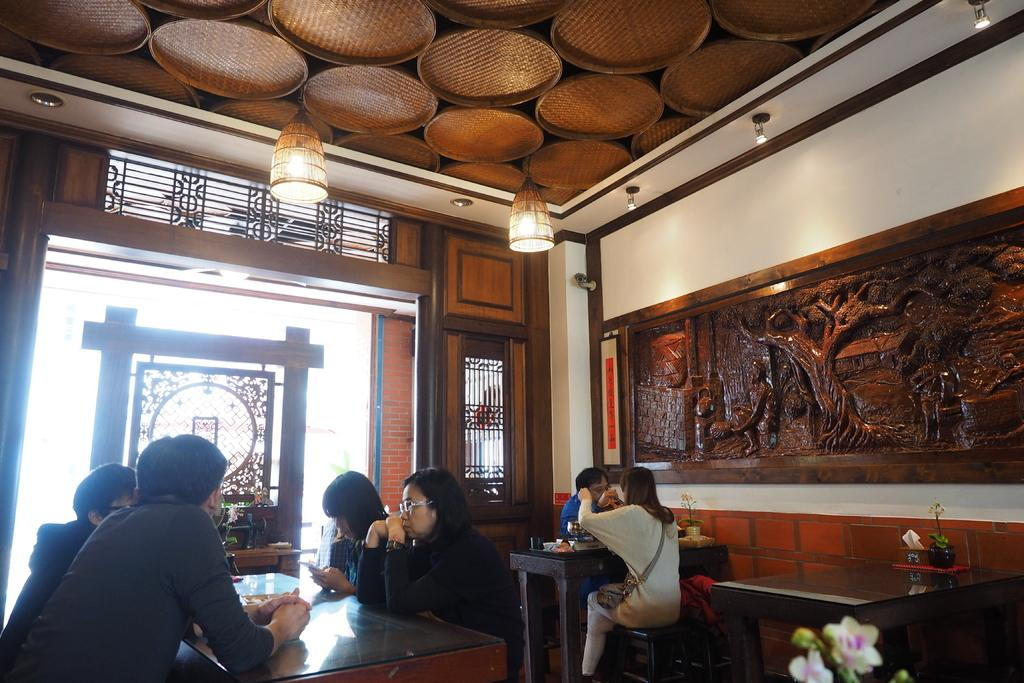What are the people in the image doing? The people in the image are sitting around a table. Can you describe any decorative elements in the image? Yes, there is a flower in the image. What can be seen in the image that provides illumination? There are lights in the image. How many chairs are visible in the image? The provided facts do not mention chairs, so it is not possible to determine the number of chairs in the image. Are there any spiders crawling on the people in the image? There is no mention of spiders in the provided facts, so it cannot be determined if any spiders are present in the image. 